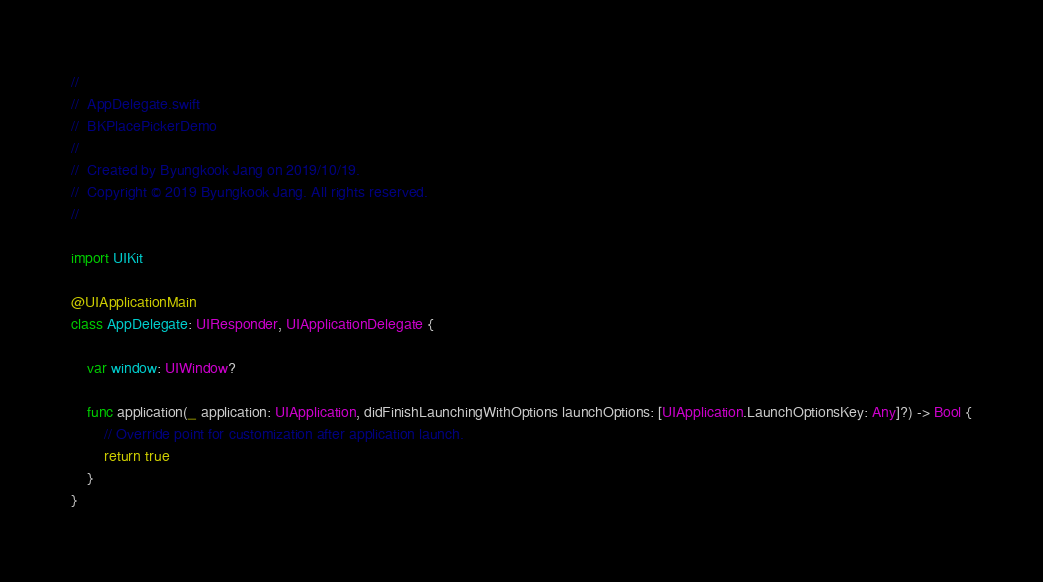Convert code to text. <code><loc_0><loc_0><loc_500><loc_500><_Swift_>//
//  AppDelegate.swift
//  BKPlacePickerDemo
//
//  Created by Byungkook Jang on 2019/10/19.
//  Copyright © 2019 Byungkook Jang. All rights reserved.
//

import UIKit

@UIApplicationMain
class AppDelegate: UIResponder, UIApplicationDelegate {

    var window: UIWindow?

    func application(_ application: UIApplication, didFinishLaunchingWithOptions launchOptions: [UIApplication.LaunchOptionsKey: Any]?) -> Bool {
        // Override point for customization after application launch.
        return true
    }
}

</code> 